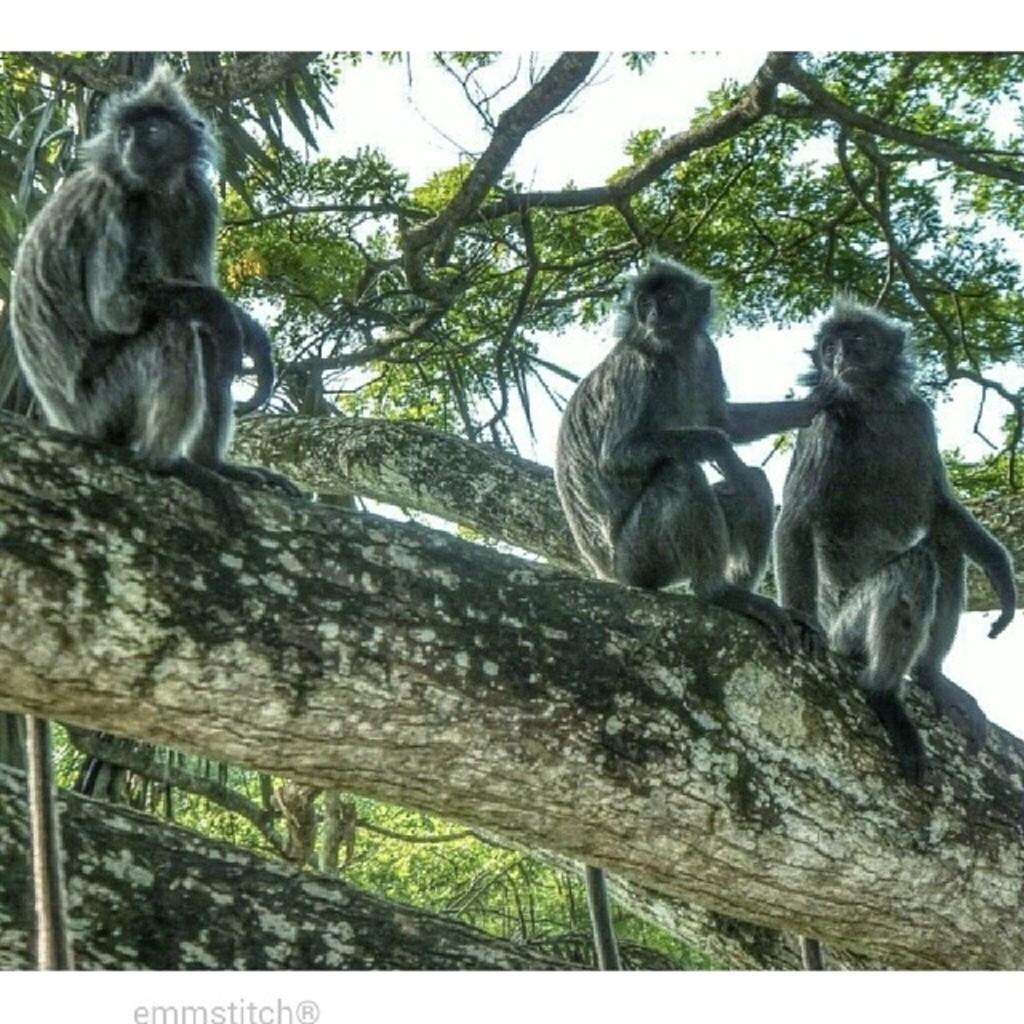What animals are on the branch of a tree in the image? There are monkeys on the branch of a tree in the image. What is the surrounding environment of the monkeys? There are trees surrounding the monkeys. What can be seen at the top of the image? The sky is visible at the top of the image. What is present at the bottom of the image? There is some text at the bottom of the image. Can you describe the exchange between the monkeys and the police in the image? There is no exchange between the monkeys and the police in the image, as there is no mention of police in the provided facts. 